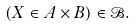Convert formula to latex. <formula><loc_0><loc_0><loc_500><loc_500>( X \in A \times B ) \in \mathcal { B } .</formula> 